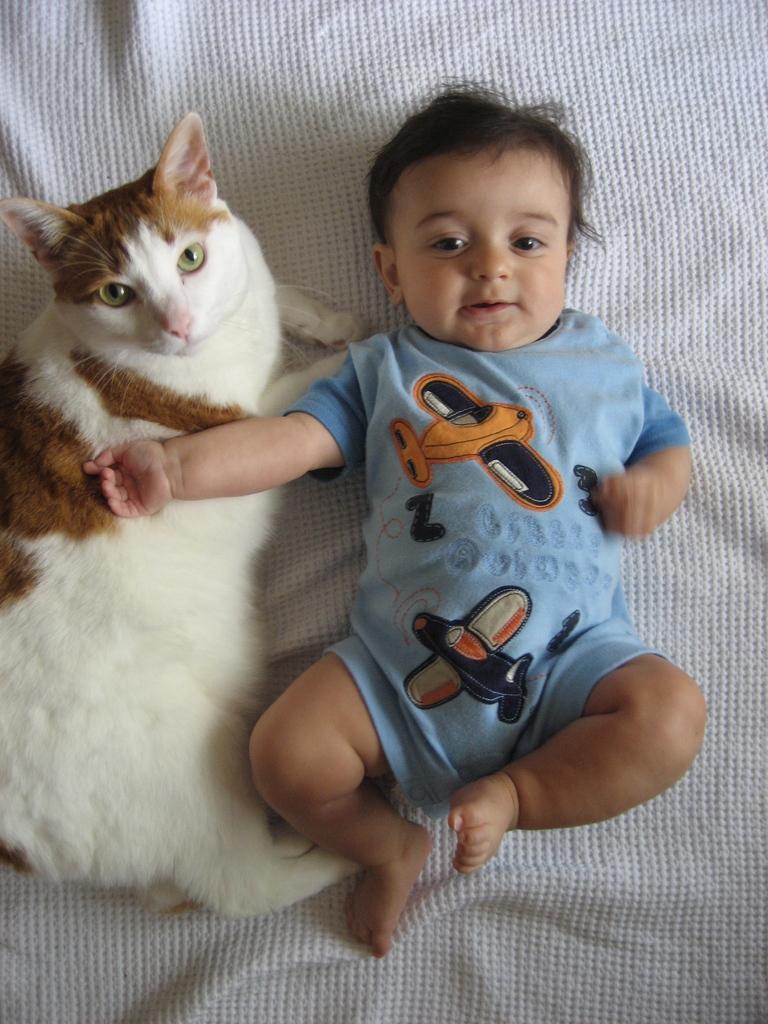Can you describe this image briefly? As we can see in the image there is a boy and white color cat. 